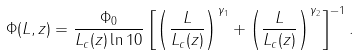<formula> <loc_0><loc_0><loc_500><loc_500>\Phi ( L , z ) = \frac { \Phi _ { 0 } } { L _ { c } ( z ) \ln 1 0 } \left [ \left ( \frac { L } { L _ { c } ( z ) } \right ) ^ { \gamma _ { 1 } } + \left ( \frac { L } { L _ { c } ( z ) } \right ) ^ { \gamma _ { 2 } } \right ] ^ { - 1 } .</formula> 